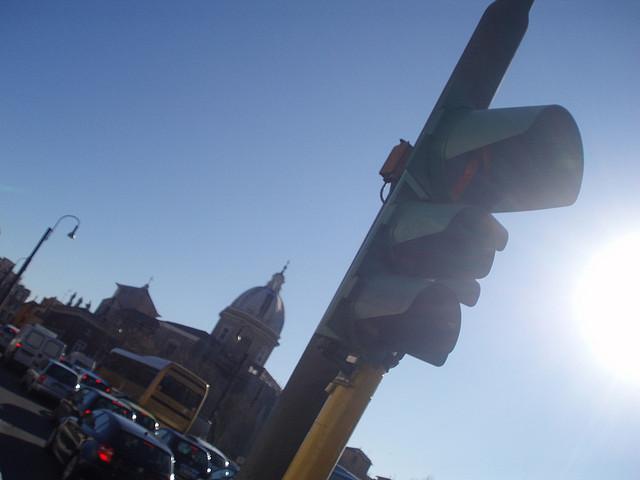What shape light is next to the building in the back?
Concise answer only. Round. How many clouds are in the sky?
Quick response, please. 0. Is there a bus in the traffic?
Be succinct. Yes. What structure is on top of the building?
Give a very brief answer. Dome. 